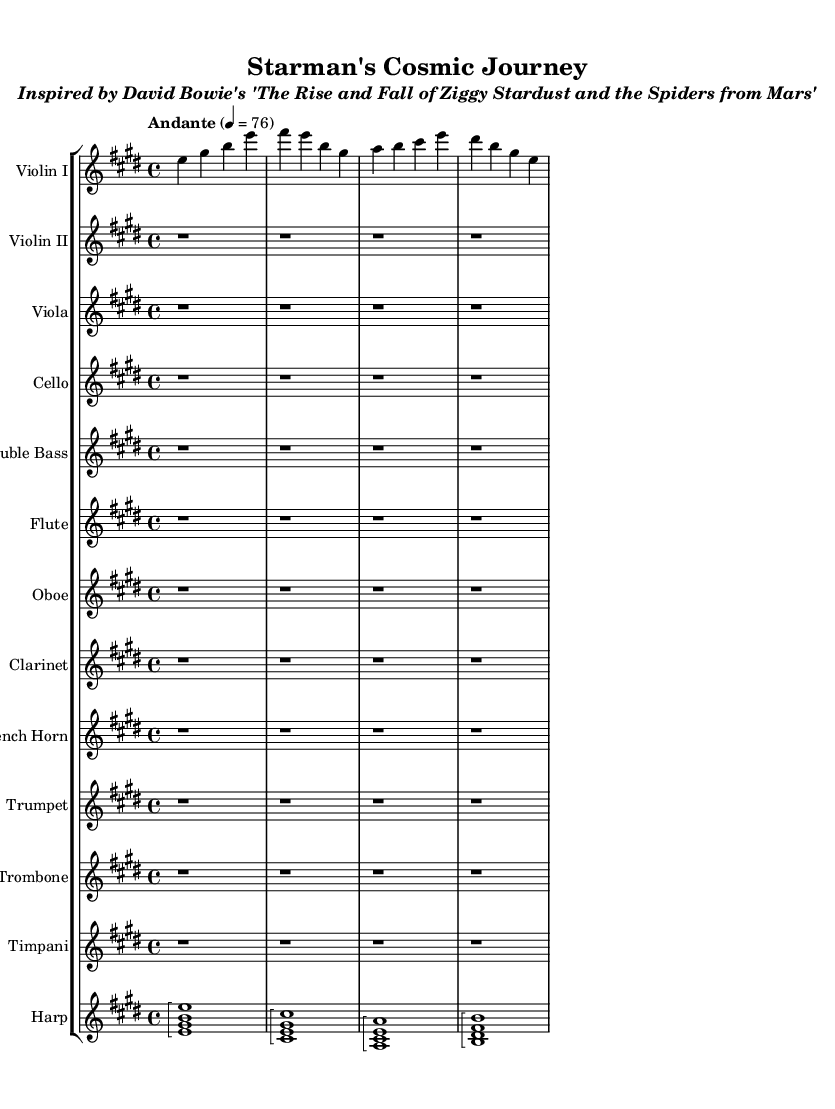What is the key signature of this music? The key signature is E major, which is indicated by four sharps on the staff (F#, C#, G#, and D#).
Answer: E major What is the time signature of this music? The time signature is indicated at the beginning of the sheet music, showing 4 beats per measure, which is represented as 4/4.
Answer: 4/4 What is the tempo marking for this piece? The tempo marking is "Andante," which conveys a moderate walking pace, and it is indicated with the metronome marking of 76 beats per minute.
Answer: Andante How many measures are in the violin I line? The violin I line consists of 4 measures, which can be counted based on the sequence of notes and rests in the given music.
Answer: 4 measures What instruments are written in the score? The score includes Violin I, Violin II, Viola, Cello, Double Bass, Flute, Oboe, Clarinet, French Horn, Trumpet, Trombone, Timpani, and Harp. These names can be found at the beginning of each staff in the score.
Answer: 12 instruments What type of music is this piece an interpretation of? This piece is inspired by David Bowie's album "The Rise and Fall of Ziggy Stardust and the Spiders from Mars," and each element in the music aims to reflect the essence of the original rock album through orchestral arrangements.
Answer: Symphonic interpretation 